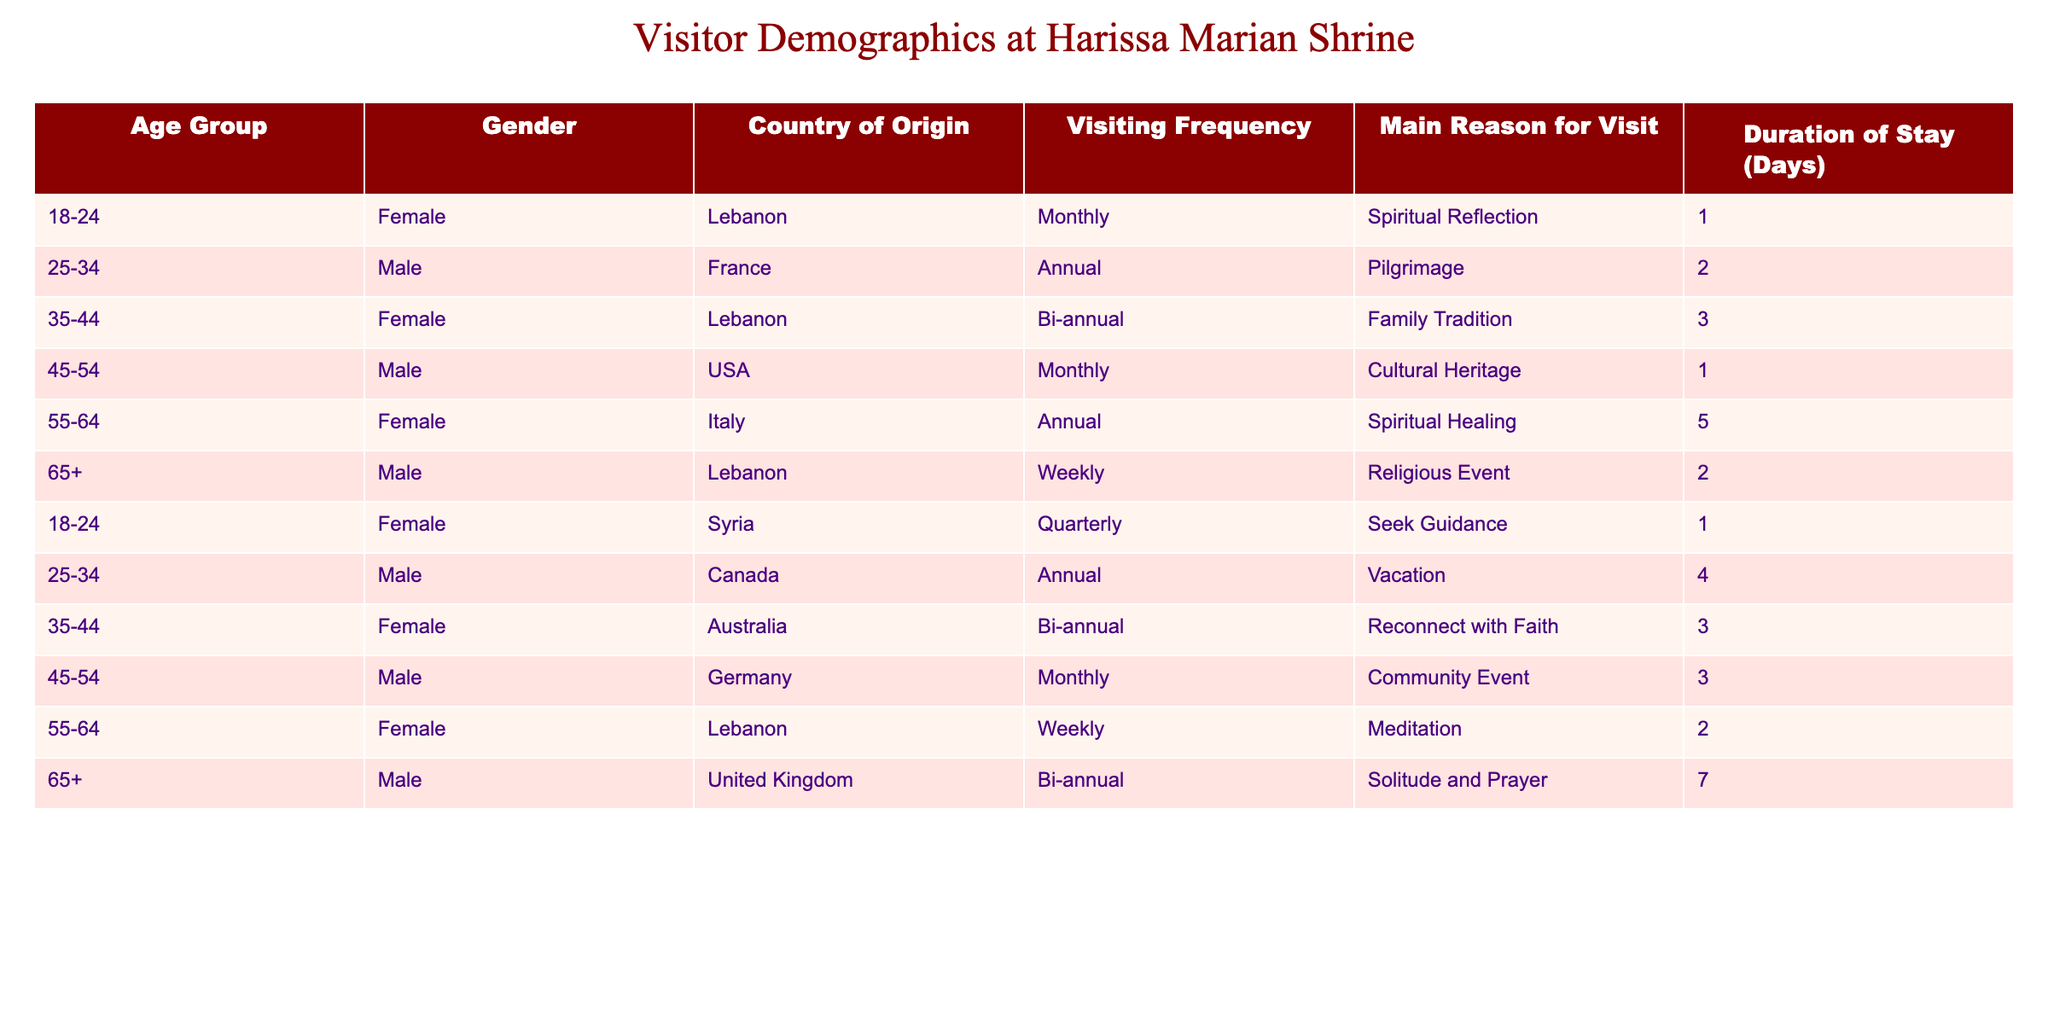What is the most common gender among visitors to the Marian shrine? By looking at the gender column in the table, we can sum up the counts for each gender. There are 6 females (18-24 Female Lebanon, 35-44 Female Lebanon, 55-64 Female Italy, 18-24 Female Syria, 55-64 Female Lebanon) and 6 males (25-34 Male France, 45-54 Male USA, 65+ Male Lebanon, 25-34 Male Canada, 45-54 Male Germany, 65+ Male United Kingdom), indicating an equal distribution.
Answer: The gender distribution is equal What country has the most visitors listed in the table? Count the occurrences of each country in the Country of Origin column. Lebanon appears 4 times (18-24 Female, 35-44 Female, 65+ Male, 55-64 Female), while other countries appear less frequently. Therefore, Lebanon is the country with the most visitors.
Answer: Lebanon has the most visitors What is the average duration of stay for all visitors? To find the average, sum up the duration values: (1 + 2 + 3 + 1 + 5 + 2 + 1 + 4 + 3 + 3 + 2 + 7) = 33. There are 12 visitors, so the average is 33/12 = 2.75 days.
Answer: The average duration of stay is 2.75 days Are most visitors to the shrine from Lebanon? Counting the visitors from Lebanon shows 4 out of 12 total visitors are from this country. Since 4 is more than one-third, it confirms that most visitors are indeed from Lebanon.
Answer: Yes, most visitors are from Lebanon How many visitors come for Spiritual Reflection? Identifying the rows where the Main Reason for Visit is Spiritual Reflection reveals 2 entries (18-24 Female Lebanon, 55-64 Female Italy). Thus, 2 visitors come for this reason.
Answer: 2 visitors come for Spiritual Reflection What is the total number of male visitors? Counting the occurrences of male visitors in the Gender column results in 6 males (25-34 Male France, 45-54 Male USA, 65+ Male Lebanon, 25-34 Male Canada, 45-54 Male Germany, 65+ Male United Kingdom). Therefore, there are 6 male visitors in total.
Answer: There are 6 male visitors Does the average age of visitors favor younger or older groups? Analyzing the age distribution presents three groups of younger visitors (18-24 and 25-34) compared to older groups (35-44, 45-54, 55-64, 65+). Given 6 visitors in younger groups and 6 visitors in older groups, the average age distribution is balanced, with no strong favor.
Answer: The average age does not favor either group; it is balanced How many visitors have a duration of stay greater than 3 days? Analyzing the Duration of Stay column, only the entries of 5 days (55-64 Female Italy) and 7 days (65+ Male United Kingdom) exceed 3 days, resulting in a count of 2 visitors.
Answer: 2 visitors have a duration of stay greater than 3 days 